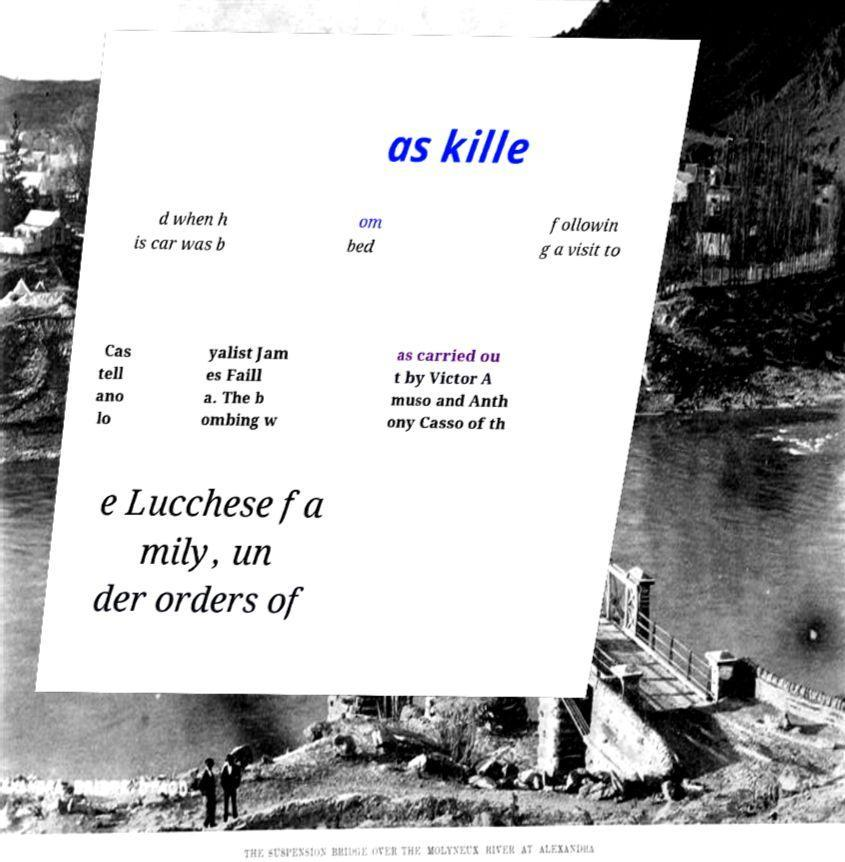Can you read and provide the text displayed in the image?This photo seems to have some interesting text. Can you extract and type it out for me? as kille d when h is car was b om bed followin g a visit to Cas tell ano lo yalist Jam es Faill a. The b ombing w as carried ou t by Victor A muso and Anth ony Casso of th e Lucchese fa mily, un der orders of 